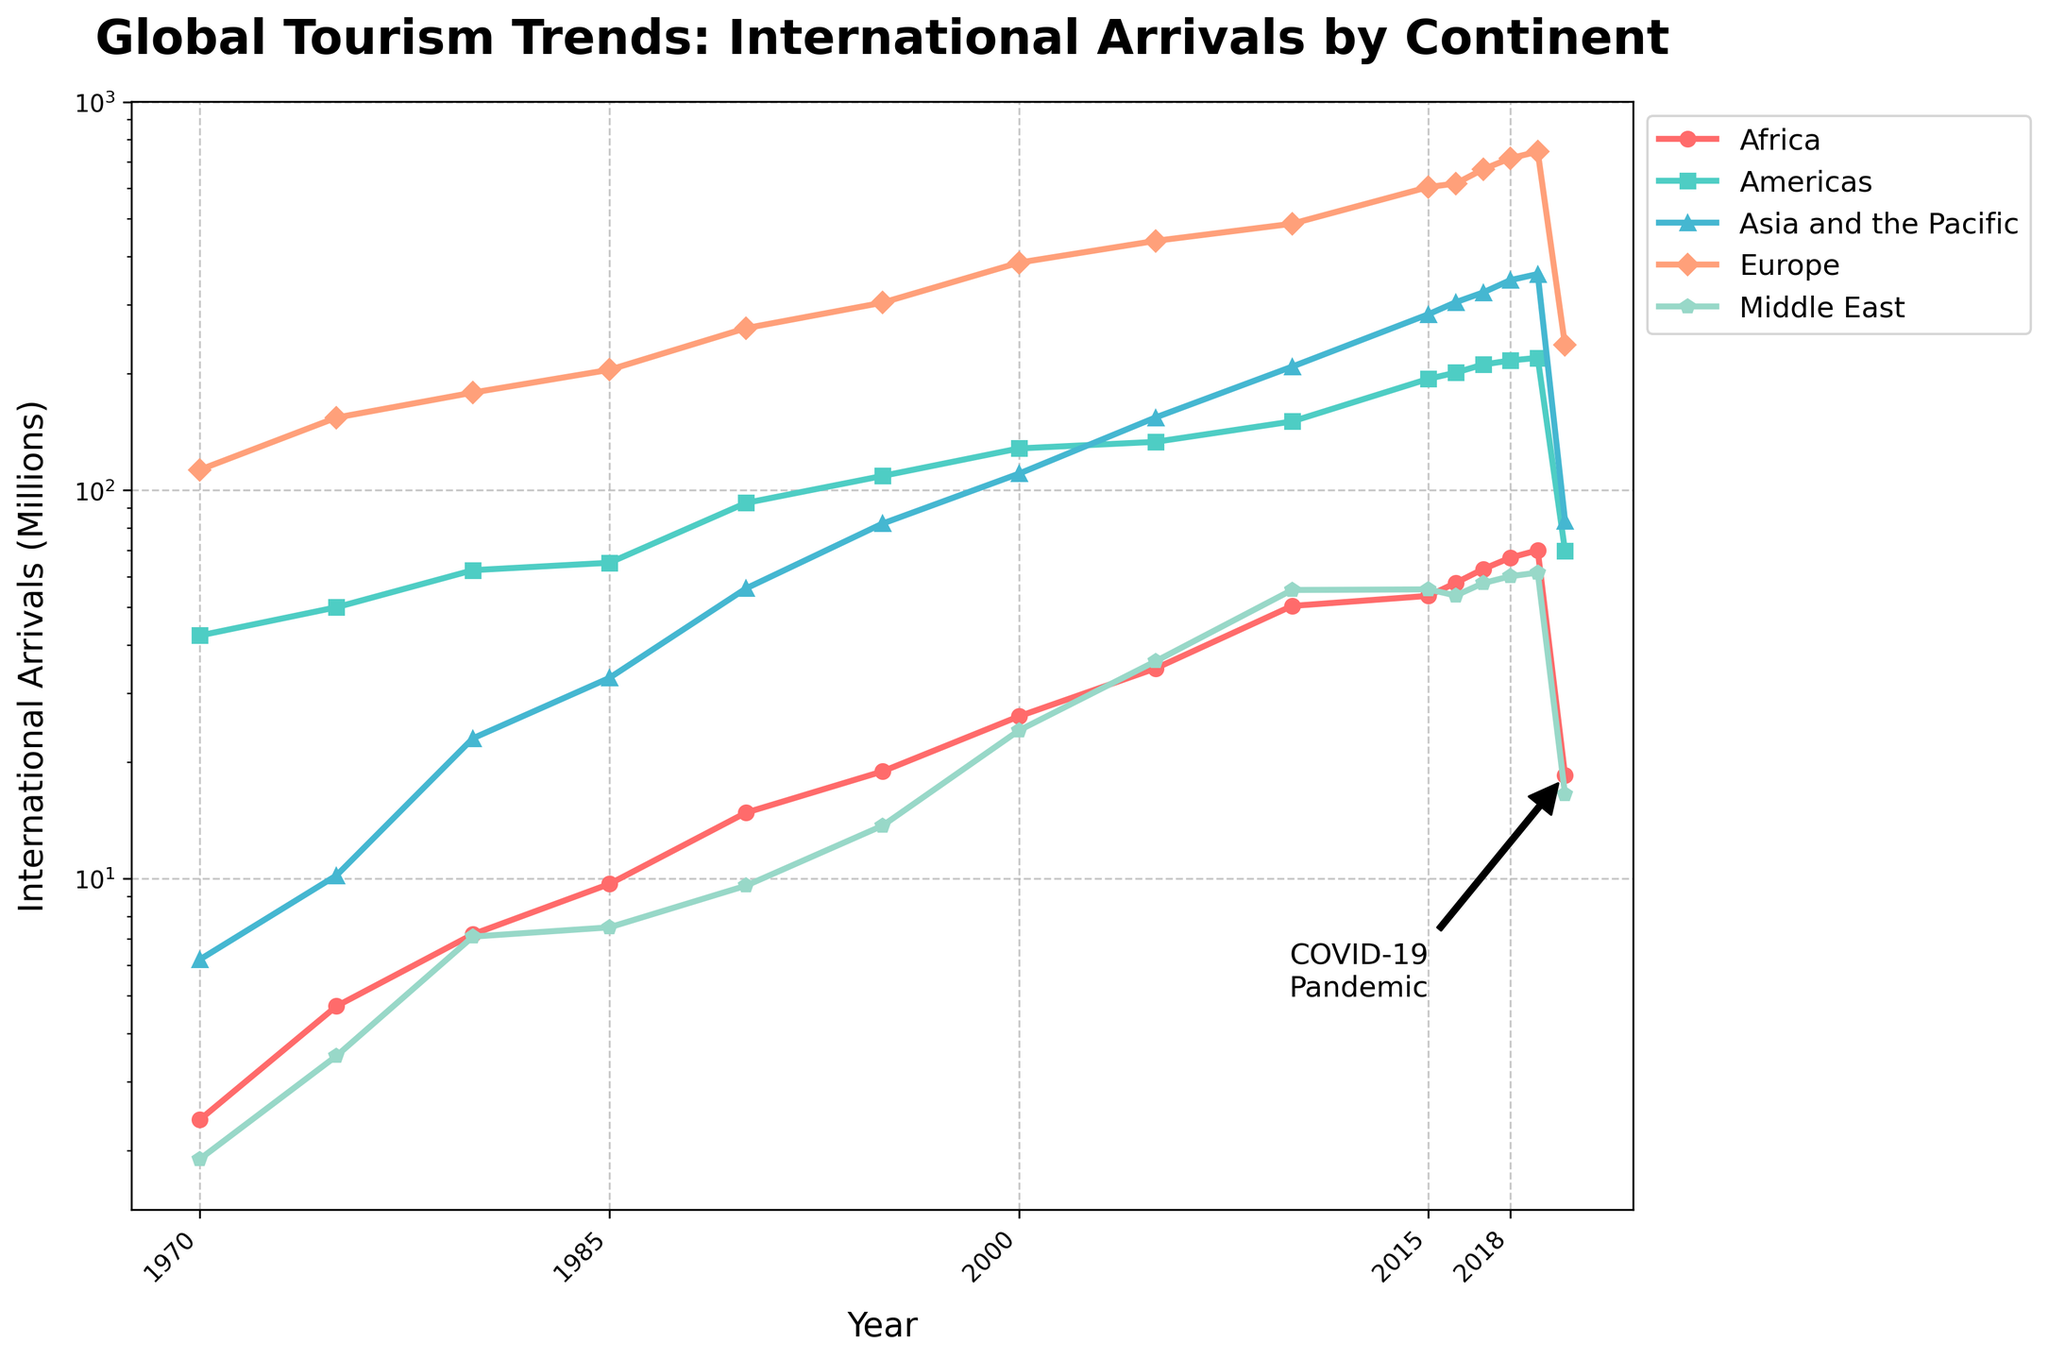What is the overall trend in international arrivals on all continents from 1970 to 2020? By observing the graph, we see an upward trend in arrivals for all continents from 1970 to 2019. There is a sharp decline in 2020, likely due to the COVID-19 pandemic as indicated by the annotation.
Answer: Upward trend till 2019, sharp decline in 2020 Which continent had the highest number of international arrivals in 2019? By looking at the height of the lines corresponding to each continent in 2019, Europe had the highest number of international arrivals.
Answer: Europe Compare the number of international arrivals in Asia and the Pacific in 1980 and 2020. What is the difference? In 1980, Asia and the Pacific had approximately 23 million arrivals. In 2020, it had around 83.5 million. The difference is 83.5 - 23 = 60.5 million.
Answer: 60.5 million Which year saw a significant increase in international arrivals for Africa? By viewing the line representing Africa, we see noticeable increases around 1990, 2000, and especially between 2010 and 2015.
Answer: 2010-2015 What visual change indicates the impact of the COVID-19 pandemic on global tourism? The sharp drop in all the lines representing international arrivals in 2020 compared to previous years visually indicates the impact. Additionally, there's an annotation pointing to 2020 indicating COVID-19.
Answer: Sharp drop in 2020, annotation What was the percentage decrease in international arrivals in the Americas from 2019 to 2020? In 2019, the Americas had 219.3 million arrivals, and in 2020, it dropped to 69.9 million. The percentage decrease is ((219.3 - 69.9) / 219.3) * 100 ≈ 68.15%.
Answer: Approximately 68.15% Which continent's line is depicted in blue, and what is its general trend from 1970 to 2020? The line representing Europe is blue. It generally shows an increasing trend until 2019, followed by a sharp decline in 2020.
Answer: Europe, increasing till 2019, sharp decline in 2020 Among the continents, which had the smallest number of international arrivals in 2000, and what was the approximate value? By inspecting the figure, the Middle East had the smallest number of international arrivals in 2000, with around 24.1 million arrivals.
Answer: Middle East, approximately 24.1 million In which year did international arrivals in the Asia and the Pacific first surpass 100 million? Looking at the line for Asia and the Pacific, it surpassed 100 million around the year 2000.
Answer: 2000 How many years did it take for Africa to increase its international arrivals from 2.4 million to over 50 million? Africa had approximately 2.4 million arrivals in 1970 and surpassed 50 million around 2010. Therefore, it took 2010 - 1970 = 40 years.
Answer: 40 years 